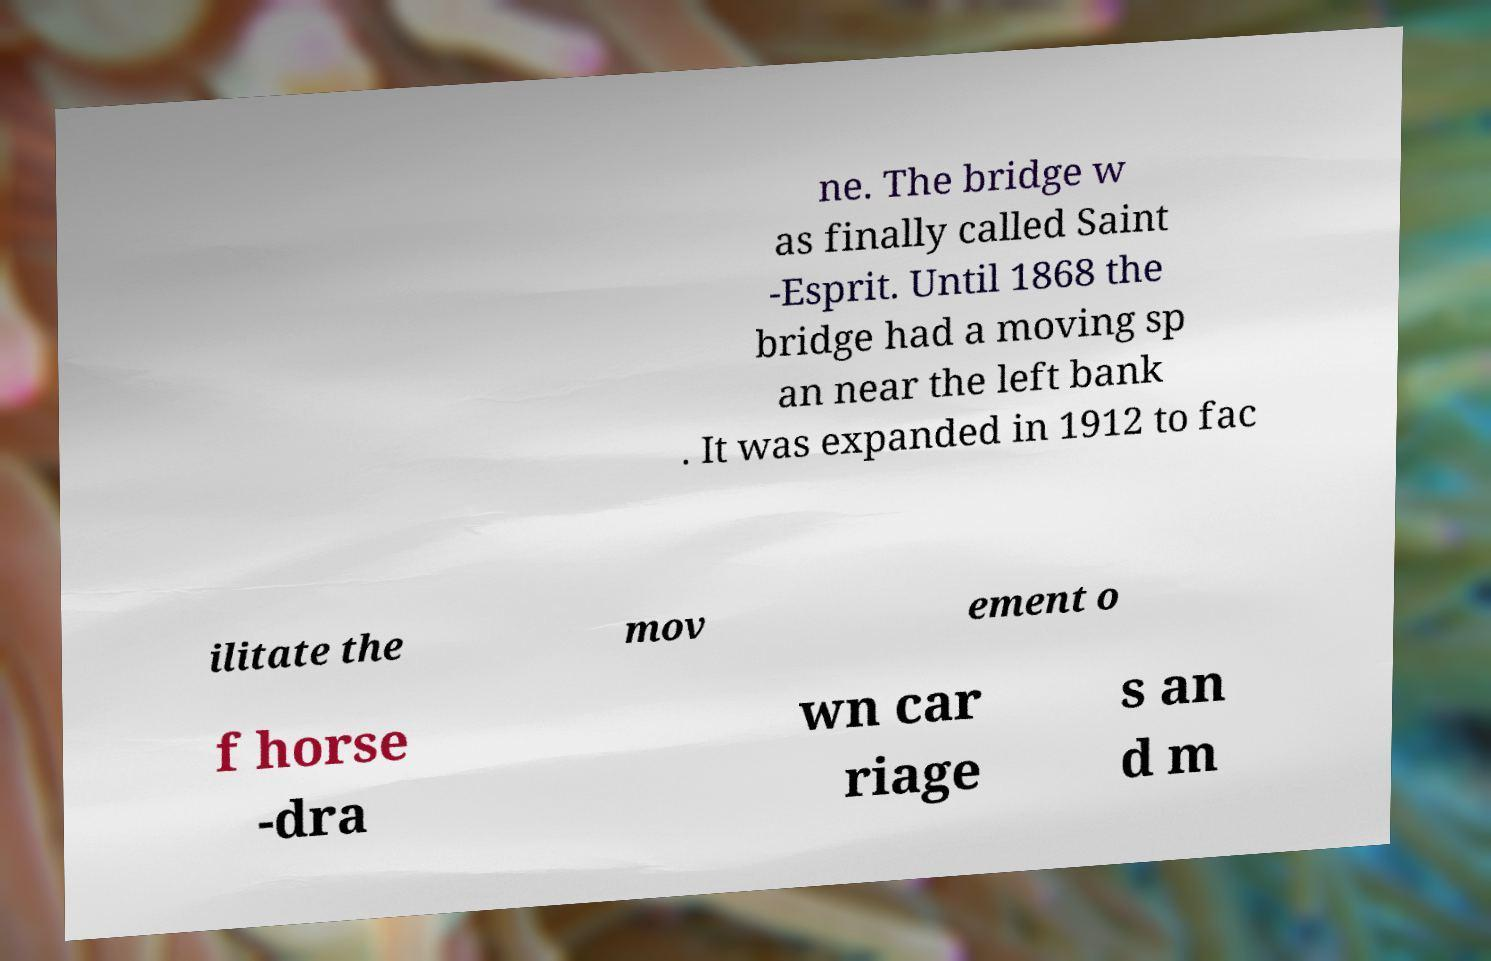Please identify and transcribe the text found in this image. ne. The bridge w as finally called Saint -Esprit. Until 1868 the bridge had a moving sp an near the left bank . It was expanded in 1912 to fac ilitate the mov ement o f horse -dra wn car riage s an d m 